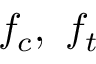Convert formula to latex. <formula><loc_0><loc_0><loc_500><loc_500>f _ { c } , \ f _ { t }</formula> 